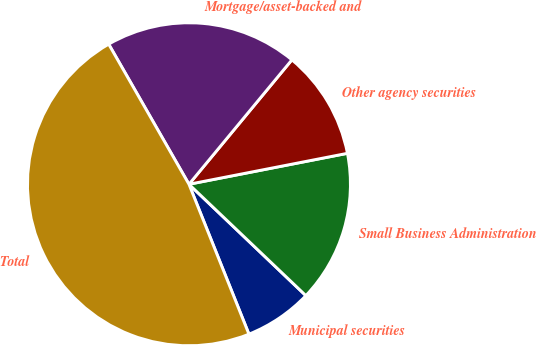Convert chart to OTSL. <chart><loc_0><loc_0><loc_500><loc_500><pie_chart><fcel>Municipal securities<fcel>Small Business Administration<fcel>Other agency securities<fcel>Mortgage/asset-backed and<fcel>Total<nl><fcel>6.83%<fcel>15.18%<fcel>10.93%<fcel>19.28%<fcel>47.77%<nl></chart> 